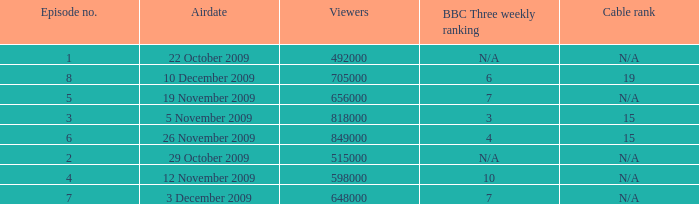Where where the bbc three weekly ranking for episode no. 5? 7.0. 